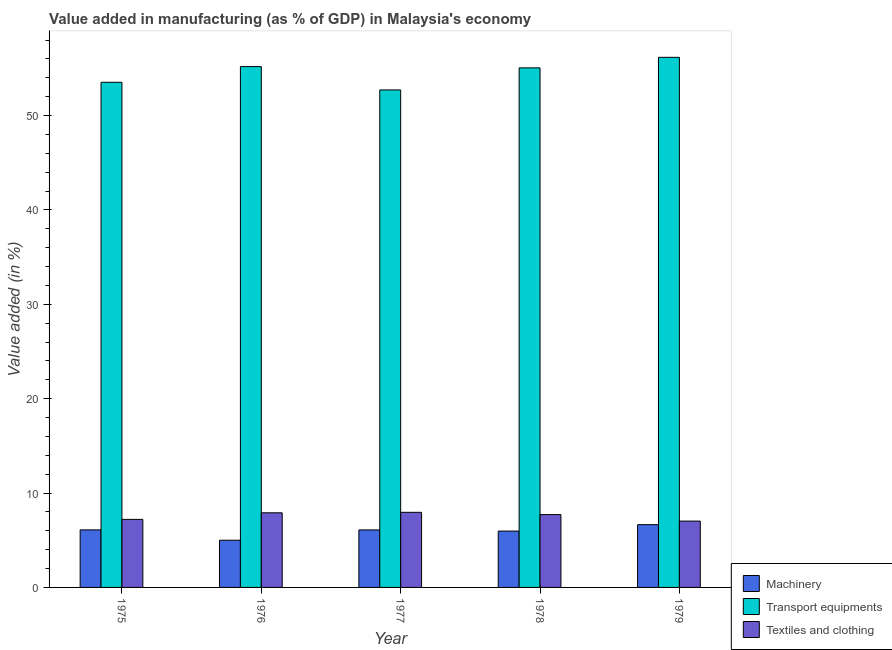How many groups of bars are there?
Give a very brief answer. 5. Are the number of bars per tick equal to the number of legend labels?
Your answer should be compact. Yes. How many bars are there on the 5th tick from the right?
Provide a short and direct response. 3. What is the label of the 2nd group of bars from the left?
Your response must be concise. 1976. What is the value added in manufacturing machinery in 1978?
Make the answer very short. 5.97. Across all years, what is the maximum value added in manufacturing transport equipments?
Offer a very short reply. 56.17. Across all years, what is the minimum value added in manufacturing textile and clothing?
Offer a terse response. 7.03. In which year was the value added in manufacturing textile and clothing maximum?
Make the answer very short. 1977. In which year was the value added in manufacturing transport equipments minimum?
Your answer should be very brief. 1977. What is the total value added in manufacturing textile and clothing in the graph?
Provide a short and direct response. 37.82. What is the difference between the value added in manufacturing textile and clothing in 1976 and that in 1979?
Keep it short and to the point. 0.88. What is the difference between the value added in manufacturing textile and clothing in 1979 and the value added in manufacturing transport equipments in 1976?
Ensure brevity in your answer.  -0.88. What is the average value added in manufacturing textile and clothing per year?
Offer a very short reply. 7.56. In the year 1978, what is the difference between the value added in manufacturing textile and clothing and value added in manufacturing transport equipments?
Offer a terse response. 0. In how many years, is the value added in manufacturing textile and clothing greater than 48 %?
Your answer should be very brief. 0. What is the ratio of the value added in manufacturing transport equipments in 1975 to that in 1979?
Offer a very short reply. 0.95. Is the difference between the value added in manufacturing textile and clothing in 1975 and 1978 greater than the difference between the value added in manufacturing transport equipments in 1975 and 1978?
Your response must be concise. No. What is the difference between the highest and the second highest value added in manufacturing textile and clothing?
Provide a succinct answer. 0.05. What is the difference between the highest and the lowest value added in manufacturing transport equipments?
Make the answer very short. 3.46. In how many years, is the value added in manufacturing machinery greater than the average value added in manufacturing machinery taken over all years?
Provide a short and direct response. 4. What does the 2nd bar from the left in 1979 represents?
Ensure brevity in your answer.  Transport equipments. What does the 1st bar from the right in 1979 represents?
Make the answer very short. Textiles and clothing. Is it the case that in every year, the sum of the value added in manufacturing machinery and value added in manufacturing transport equipments is greater than the value added in manufacturing textile and clothing?
Your answer should be very brief. Yes. How many bars are there?
Offer a very short reply. 15. Are all the bars in the graph horizontal?
Keep it short and to the point. No. Are the values on the major ticks of Y-axis written in scientific E-notation?
Offer a very short reply. No. Does the graph contain any zero values?
Give a very brief answer. No. Does the graph contain grids?
Ensure brevity in your answer.  No. Where does the legend appear in the graph?
Keep it short and to the point. Bottom right. What is the title of the graph?
Your response must be concise. Value added in manufacturing (as % of GDP) in Malaysia's economy. What is the label or title of the X-axis?
Your response must be concise. Year. What is the label or title of the Y-axis?
Ensure brevity in your answer.  Value added (in %). What is the Value added (in %) of Machinery in 1975?
Your answer should be compact. 6.1. What is the Value added (in %) of Transport equipments in 1975?
Your response must be concise. 53.52. What is the Value added (in %) in Textiles and clothing in 1975?
Keep it short and to the point. 7.21. What is the Value added (in %) of Machinery in 1976?
Provide a short and direct response. 5. What is the Value added (in %) in Transport equipments in 1976?
Your answer should be very brief. 55.19. What is the Value added (in %) in Textiles and clothing in 1976?
Offer a terse response. 7.91. What is the Value added (in %) in Machinery in 1977?
Offer a terse response. 6.09. What is the Value added (in %) in Transport equipments in 1977?
Your answer should be very brief. 52.71. What is the Value added (in %) in Textiles and clothing in 1977?
Make the answer very short. 7.96. What is the Value added (in %) of Machinery in 1978?
Keep it short and to the point. 5.97. What is the Value added (in %) of Transport equipments in 1978?
Offer a terse response. 55.05. What is the Value added (in %) of Textiles and clothing in 1978?
Give a very brief answer. 7.72. What is the Value added (in %) of Machinery in 1979?
Make the answer very short. 6.65. What is the Value added (in %) in Transport equipments in 1979?
Keep it short and to the point. 56.17. What is the Value added (in %) in Textiles and clothing in 1979?
Your response must be concise. 7.03. Across all years, what is the maximum Value added (in %) in Machinery?
Your answer should be very brief. 6.65. Across all years, what is the maximum Value added (in %) of Transport equipments?
Offer a terse response. 56.17. Across all years, what is the maximum Value added (in %) in Textiles and clothing?
Offer a terse response. 7.96. Across all years, what is the minimum Value added (in %) in Machinery?
Make the answer very short. 5. Across all years, what is the minimum Value added (in %) in Transport equipments?
Ensure brevity in your answer.  52.71. Across all years, what is the minimum Value added (in %) of Textiles and clothing?
Ensure brevity in your answer.  7.03. What is the total Value added (in %) in Machinery in the graph?
Ensure brevity in your answer.  29.81. What is the total Value added (in %) in Transport equipments in the graph?
Provide a succinct answer. 272.64. What is the total Value added (in %) of Textiles and clothing in the graph?
Ensure brevity in your answer.  37.82. What is the difference between the Value added (in %) of Machinery in 1975 and that in 1976?
Your answer should be compact. 1.1. What is the difference between the Value added (in %) in Transport equipments in 1975 and that in 1976?
Provide a succinct answer. -1.67. What is the difference between the Value added (in %) in Textiles and clothing in 1975 and that in 1976?
Make the answer very short. -0.7. What is the difference between the Value added (in %) of Machinery in 1975 and that in 1977?
Your answer should be very brief. 0.01. What is the difference between the Value added (in %) in Transport equipments in 1975 and that in 1977?
Your answer should be compact. 0.81. What is the difference between the Value added (in %) in Textiles and clothing in 1975 and that in 1977?
Give a very brief answer. -0.75. What is the difference between the Value added (in %) in Machinery in 1975 and that in 1978?
Your answer should be very brief. 0.13. What is the difference between the Value added (in %) in Transport equipments in 1975 and that in 1978?
Provide a short and direct response. -1.53. What is the difference between the Value added (in %) in Textiles and clothing in 1975 and that in 1978?
Your answer should be very brief. -0.51. What is the difference between the Value added (in %) of Machinery in 1975 and that in 1979?
Your answer should be very brief. -0.55. What is the difference between the Value added (in %) in Transport equipments in 1975 and that in 1979?
Provide a succinct answer. -2.65. What is the difference between the Value added (in %) of Textiles and clothing in 1975 and that in 1979?
Provide a succinct answer. 0.18. What is the difference between the Value added (in %) in Machinery in 1976 and that in 1977?
Keep it short and to the point. -1.09. What is the difference between the Value added (in %) in Transport equipments in 1976 and that in 1977?
Provide a succinct answer. 2.48. What is the difference between the Value added (in %) of Textiles and clothing in 1976 and that in 1977?
Provide a short and direct response. -0.05. What is the difference between the Value added (in %) in Machinery in 1976 and that in 1978?
Ensure brevity in your answer.  -0.97. What is the difference between the Value added (in %) in Transport equipments in 1976 and that in 1978?
Provide a short and direct response. 0.14. What is the difference between the Value added (in %) of Textiles and clothing in 1976 and that in 1978?
Provide a short and direct response. 0.19. What is the difference between the Value added (in %) in Machinery in 1976 and that in 1979?
Your answer should be compact. -1.65. What is the difference between the Value added (in %) of Transport equipments in 1976 and that in 1979?
Your response must be concise. -0.98. What is the difference between the Value added (in %) of Textiles and clothing in 1976 and that in 1979?
Offer a terse response. 0.88. What is the difference between the Value added (in %) in Machinery in 1977 and that in 1978?
Keep it short and to the point. 0.12. What is the difference between the Value added (in %) in Transport equipments in 1977 and that in 1978?
Ensure brevity in your answer.  -2.34. What is the difference between the Value added (in %) in Textiles and clothing in 1977 and that in 1978?
Provide a short and direct response. 0.24. What is the difference between the Value added (in %) in Machinery in 1977 and that in 1979?
Make the answer very short. -0.56. What is the difference between the Value added (in %) of Transport equipments in 1977 and that in 1979?
Provide a succinct answer. -3.46. What is the difference between the Value added (in %) of Textiles and clothing in 1977 and that in 1979?
Give a very brief answer. 0.93. What is the difference between the Value added (in %) of Machinery in 1978 and that in 1979?
Provide a succinct answer. -0.68. What is the difference between the Value added (in %) in Transport equipments in 1978 and that in 1979?
Give a very brief answer. -1.12. What is the difference between the Value added (in %) in Textiles and clothing in 1978 and that in 1979?
Offer a terse response. 0.69. What is the difference between the Value added (in %) of Machinery in 1975 and the Value added (in %) of Transport equipments in 1976?
Provide a short and direct response. -49.09. What is the difference between the Value added (in %) in Machinery in 1975 and the Value added (in %) in Textiles and clothing in 1976?
Make the answer very short. -1.81. What is the difference between the Value added (in %) of Transport equipments in 1975 and the Value added (in %) of Textiles and clothing in 1976?
Keep it short and to the point. 45.62. What is the difference between the Value added (in %) in Machinery in 1975 and the Value added (in %) in Transport equipments in 1977?
Your response must be concise. -46.61. What is the difference between the Value added (in %) of Machinery in 1975 and the Value added (in %) of Textiles and clothing in 1977?
Provide a succinct answer. -1.86. What is the difference between the Value added (in %) in Transport equipments in 1975 and the Value added (in %) in Textiles and clothing in 1977?
Provide a short and direct response. 45.56. What is the difference between the Value added (in %) of Machinery in 1975 and the Value added (in %) of Transport equipments in 1978?
Keep it short and to the point. -48.95. What is the difference between the Value added (in %) of Machinery in 1975 and the Value added (in %) of Textiles and clothing in 1978?
Your response must be concise. -1.62. What is the difference between the Value added (in %) of Transport equipments in 1975 and the Value added (in %) of Textiles and clothing in 1978?
Provide a short and direct response. 45.8. What is the difference between the Value added (in %) in Machinery in 1975 and the Value added (in %) in Transport equipments in 1979?
Give a very brief answer. -50.07. What is the difference between the Value added (in %) of Machinery in 1975 and the Value added (in %) of Textiles and clothing in 1979?
Provide a short and direct response. -0.93. What is the difference between the Value added (in %) of Transport equipments in 1975 and the Value added (in %) of Textiles and clothing in 1979?
Keep it short and to the point. 46.49. What is the difference between the Value added (in %) in Machinery in 1976 and the Value added (in %) in Transport equipments in 1977?
Your answer should be compact. -47.71. What is the difference between the Value added (in %) of Machinery in 1976 and the Value added (in %) of Textiles and clothing in 1977?
Make the answer very short. -2.96. What is the difference between the Value added (in %) in Transport equipments in 1976 and the Value added (in %) in Textiles and clothing in 1977?
Provide a short and direct response. 47.23. What is the difference between the Value added (in %) in Machinery in 1976 and the Value added (in %) in Transport equipments in 1978?
Provide a succinct answer. -50.05. What is the difference between the Value added (in %) of Machinery in 1976 and the Value added (in %) of Textiles and clothing in 1978?
Offer a terse response. -2.72. What is the difference between the Value added (in %) of Transport equipments in 1976 and the Value added (in %) of Textiles and clothing in 1978?
Provide a succinct answer. 47.47. What is the difference between the Value added (in %) in Machinery in 1976 and the Value added (in %) in Transport equipments in 1979?
Give a very brief answer. -51.17. What is the difference between the Value added (in %) of Machinery in 1976 and the Value added (in %) of Textiles and clothing in 1979?
Offer a terse response. -2.03. What is the difference between the Value added (in %) in Transport equipments in 1976 and the Value added (in %) in Textiles and clothing in 1979?
Provide a short and direct response. 48.16. What is the difference between the Value added (in %) in Machinery in 1977 and the Value added (in %) in Transport equipments in 1978?
Offer a terse response. -48.96. What is the difference between the Value added (in %) in Machinery in 1977 and the Value added (in %) in Textiles and clothing in 1978?
Offer a terse response. -1.63. What is the difference between the Value added (in %) of Transport equipments in 1977 and the Value added (in %) of Textiles and clothing in 1978?
Your answer should be very brief. 44.99. What is the difference between the Value added (in %) in Machinery in 1977 and the Value added (in %) in Transport equipments in 1979?
Give a very brief answer. -50.08. What is the difference between the Value added (in %) of Machinery in 1977 and the Value added (in %) of Textiles and clothing in 1979?
Keep it short and to the point. -0.94. What is the difference between the Value added (in %) of Transport equipments in 1977 and the Value added (in %) of Textiles and clothing in 1979?
Make the answer very short. 45.68. What is the difference between the Value added (in %) of Machinery in 1978 and the Value added (in %) of Transport equipments in 1979?
Your answer should be very brief. -50.2. What is the difference between the Value added (in %) of Machinery in 1978 and the Value added (in %) of Textiles and clothing in 1979?
Offer a terse response. -1.06. What is the difference between the Value added (in %) in Transport equipments in 1978 and the Value added (in %) in Textiles and clothing in 1979?
Your answer should be very brief. 48.02. What is the average Value added (in %) of Machinery per year?
Your answer should be compact. 5.96. What is the average Value added (in %) in Transport equipments per year?
Offer a very short reply. 54.53. What is the average Value added (in %) in Textiles and clothing per year?
Provide a succinct answer. 7.56. In the year 1975, what is the difference between the Value added (in %) in Machinery and Value added (in %) in Transport equipments?
Your answer should be compact. -47.43. In the year 1975, what is the difference between the Value added (in %) of Machinery and Value added (in %) of Textiles and clothing?
Provide a short and direct response. -1.11. In the year 1975, what is the difference between the Value added (in %) of Transport equipments and Value added (in %) of Textiles and clothing?
Provide a succinct answer. 46.31. In the year 1976, what is the difference between the Value added (in %) of Machinery and Value added (in %) of Transport equipments?
Keep it short and to the point. -50.19. In the year 1976, what is the difference between the Value added (in %) of Machinery and Value added (in %) of Textiles and clothing?
Your response must be concise. -2.91. In the year 1976, what is the difference between the Value added (in %) of Transport equipments and Value added (in %) of Textiles and clothing?
Give a very brief answer. 47.28. In the year 1977, what is the difference between the Value added (in %) of Machinery and Value added (in %) of Transport equipments?
Offer a terse response. -46.62. In the year 1977, what is the difference between the Value added (in %) of Machinery and Value added (in %) of Textiles and clothing?
Offer a very short reply. -1.87. In the year 1977, what is the difference between the Value added (in %) in Transport equipments and Value added (in %) in Textiles and clothing?
Offer a very short reply. 44.75. In the year 1978, what is the difference between the Value added (in %) of Machinery and Value added (in %) of Transport equipments?
Ensure brevity in your answer.  -49.08. In the year 1978, what is the difference between the Value added (in %) in Machinery and Value added (in %) in Textiles and clothing?
Provide a short and direct response. -1.75. In the year 1978, what is the difference between the Value added (in %) in Transport equipments and Value added (in %) in Textiles and clothing?
Your answer should be very brief. 47.33. In the year 1979, what is the difference between the Value added (in %) of Machinery and Value added (in %) of Transport equipments?
Give a very brief answer. -49.52. In the year 1979, what is the difference between the Value added (in %) in Machinery and Value added (in %) in Textiles and clothing?
Your response must be concise. -0.38. In the year 1979, what is the difference between the Value added (in %) of Transport equipments and Value added (in %) of Textiles and clothing?
Your answer should be compact. 49.14. What is the ratio of the Value added (in %) in Machinery in 1975 to that in 1976?
Your answer should be very brief. 1.22. What is the ratio of the Value added (in %) of Transport equipments in 1975 to that in 1976?
Your answer should be compact. 0.97. What is the ratio of the Value added (in %) in Textiles and clothing in 1975 to that in 1976?
Offer a terse response. 0.91. What is the ratio of the Value added (in %) of Transport equipments in 1975 to that in 1977?
Your answer should be very brief. 1.02. What is the ratio of the Value added (in %) of Textiles and clothing in 1975 to that in 1977?
Your response must be concise. 0.91. What is the ratio of the Value added (in %) of Machinery in 1975 to that in 1978?
Make the answer very short. 1.02. What is the ratio of the Value added (in %) of Transport equipments in 1975 to that in 1978?
Provide a succinct answer. 0.97. What is the ratio of the Value added (in %) of Textiles and clothing in 1975 to that in 1978?
Ensure brevity in your answer.  0.93. What is the ratio of the Value added (in %) of Machinery in 1975 to that in 1979?
Make the answer very short. 0.92. What is the ratio of the Value added (in %) of Transport equipments in 1975 to that in 1979?
Make the answer very short. 0.95. What is the ratio of the Value added (in %) in Textiles and clothing in 1975 to that in 1979?
Provide a succinct answer. 1.03. What is the ratio of the Value added (in %) in Machinery in 1976 to that in 1977?
Your answer should be compact. 0.82. What is the ratio of the Value added (in %) of Transport equipments in 1976 to that in 1977?
Offer a very short reply. 1.05. What is the ratio of the Value added (in %) of Textiles and clothing in 1976 to that in 1977?
Keep it short and to the point. 0.99. What is the ratio of the Value added (in %) of Machinery in 1976 to that in 1978?
Provide a short and direct response. 0.84. What is the ratio of the Value added (in %) of Textiles and clothing in 1976 to that in 1978?
Your answer should be very brief. 1.02. What is the ratio of the Value added (in %) of Machinery in 1976 to that in 1979?
Your response must be concise. 0.75. What is the ratio of the Value added (in %) in Transport equipments in 1976 to that in 1979?
Provide a succinct answer. 0.98. What is the ratio of the Value added (in %) in Textiles and clothing in 1976 to that in 1979?
Give a very brief answer. 1.12. What is the ratio of the Value added (in %) in Machinery in 1977 to that in 1978?
Offer a terse response. 1.02. What is the ratio of the Value added (in %) of Transport equipments in 1977 to that in 1978?
Your answer should be very brief. 0.96. What is the ratio of the Value added (in %) of Textiles and clothing in 1977 to that in 1978?
Your answer should be very brief. 1.03. What is the ratio of the Value added (in %) of Machinery in 1977 to that in 1979?
Offer a terse response. 0.92. What is the ratio of the Value added (in %) in Transport equipments in 1977 to that in 1979?
Your response must be concise. 0.94. What is the ratio of the Value added (in %) of Textiles and clothing in 1977 to that in 1979?
Keep it short and to the point. 1.13. What is the ratio of the Value added (in %) of Machinery in 1978 to that in 1979?
Your response must be concise. 0.9. What is the ratio of the Value added (in %) of Transport equipments in 1978 to that in 1979?
Provide a succinct answer. 0.98. What is the ratio of the Value added (in %) in Textiles and clothing in 1978 to that in 1979?
Your answer should be very brief. 1.1. What is the difference between the highest and the second highest Value added (in %) of Machinery?
Make the answer very short. 0.55. What is the difference between the highest and the second highest Value added (in %) of Transport equipments?
Your answer should be very brief. 0.98. What is the difference between the highest and the second highest Value added (in %) in Textiles and clothing?
Offer a terse response. 0.05. What is the difference between the highest and the lowest Value added (in %) of Machinery?
Provide a short and direct response. 1.65. What is the difference between the highest and the lowest Value added (in %) in Transport equipments?
Offer a very short reply. 3.46. What is the difference between the highest and the lowest Value added (in %) in Textiles and clothing?
Your answer should be very brief. 0.93. 